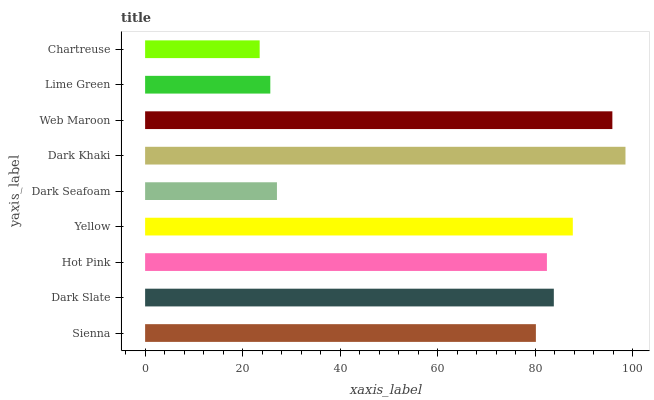Is Chartreuse the minimum?
Answer yes or no. Yes. Is Dark Khaki the maximum?
Answer yes or no. Yes. Is Dark Slate the minimum?
Answer yes or no. No. Is Dark Slate the maximum?
Answer yes or no. No. Is Dark Slate greater than Sienna?
Answer yes or no. Yes. Is Sienna less than Dark Slate?
Answer yes or no. Yes. Is Sienna greater than Dark Slate?
Answer yes or no. No. Is Dark Slate less than Sienna?
Answer yes or no. No. Is Hot Pink the high median?
Answer yes or no. Yes. Is Hot Pink the low median?
Answer yes or no. Yes. Is Sienna the high median?
Answer yes or no. No. Is Chartreuse the low median?
Answer yes or no. No. 